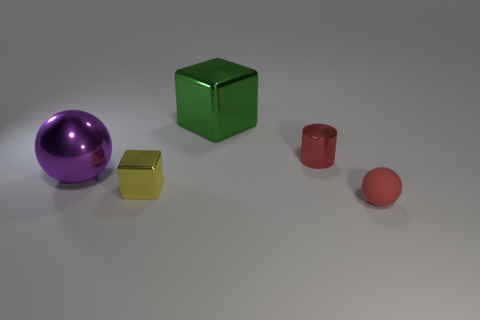Add 1 rubber objects. How many objects exist? 6 Subtract all balls. How many objects are left? 3 Add 3 large yellow balls. How many large yellow balls exist? 3 Subtract 1 red cylinders. How many objects are left? 4 Subtract all metallic blocks. Subtract all big metal spheres. How many objects are left? 2 Add 3 red balls. How many red balls are left? 4 